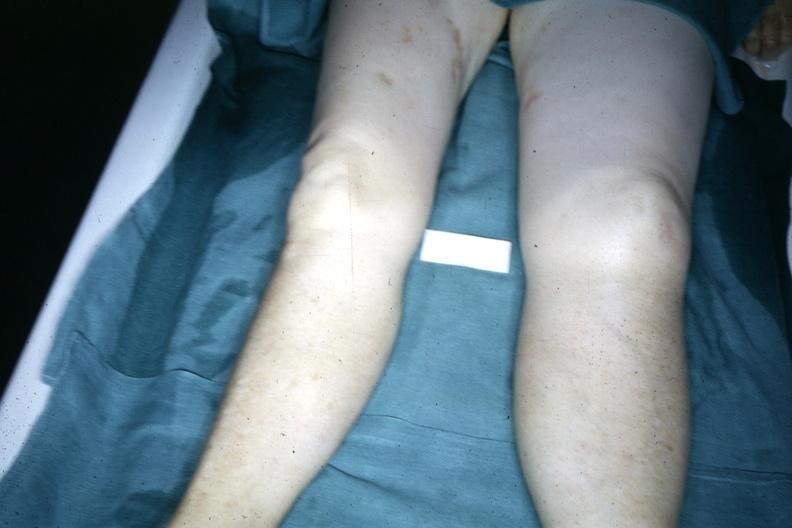s legs demonstrated with one about twice the size of the other due to malignant lymphoma involving lymphatic drainage?
Answer the question using a single word or phrase. Yes 